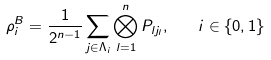Convert formula to latex. <formula><loc_0><loc_0><loc_500><loc_500>\rho ^ { B } _ { i } = \frac { 1 } { 2 ^ { n - 1 } } \sum _ { { j } \in \Lambda _ { i } } \bigotimes ^ { n } _ { l = 1 } P _ { l j _ { l } } , \quad i \in \{ 0 , 1 \}</formula> 